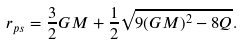<formula> <loc_0><loc_0><loc_500><loc_500>r _ { p s } = \frac { 3 } { 2 } G M + \frac { 1 } { 2 } \sqrt { 9 ( G M ) ^ { 2 } - 8 Q } .</formula> 